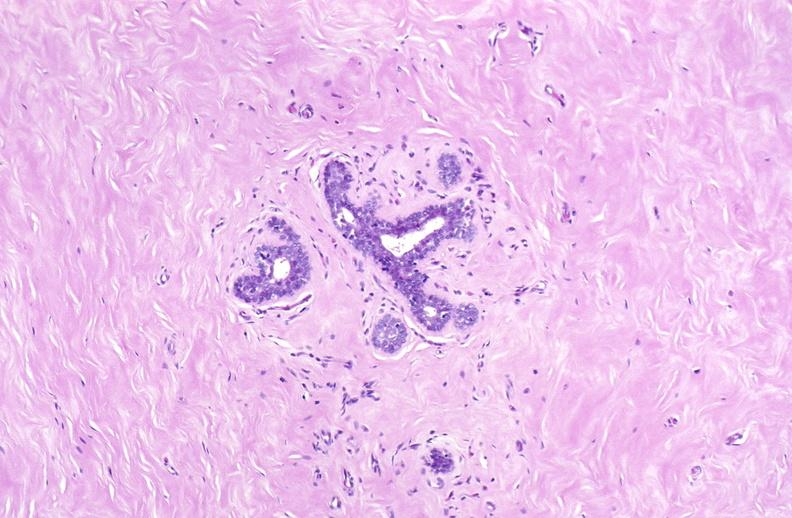what does this image show?
Answer the question using a single word or phrase. Breast 